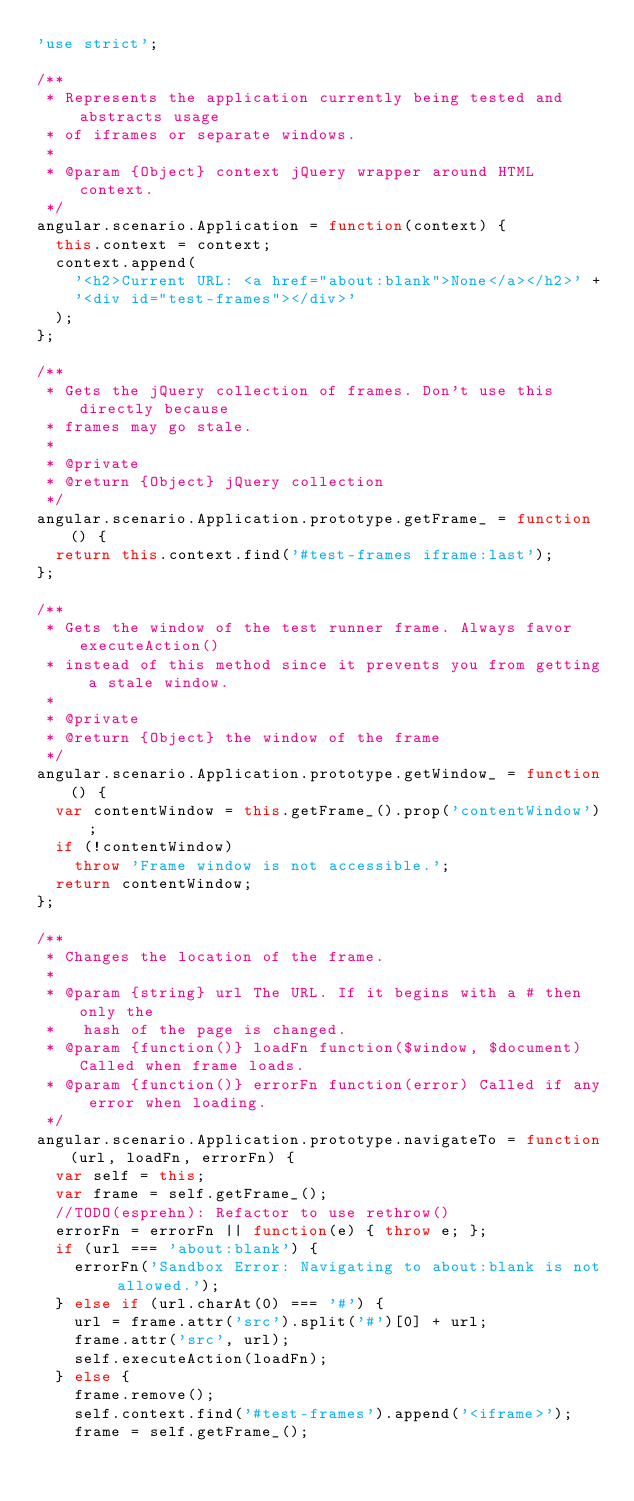Convert code to text. <code><loc_0><loc_0><loc_500><loc_500><_JavaScript_>'use strict';

/**
 * Represents the application currently being tested and abstracts usage
 * of iframes or separate windows.
 *
 * @param {Object} context jQuery wrapper around HTML context.
 */
angular.scenario.Application = function(context) {
  this.context = context;
  context.append(
    '<h2>Current URL: <a href="about:blank">None</a></h2>' +
    '<div id="test-frames"></div>'
  );
};

/**
 * Gets the jQuery collection of frames. Don't use this directly because
 * frames may go stale.
 *
 * @private
 * @return {Object} jQuery collection
 */
angular.scenario.Application.prototype.getFrame_ = function() {
  return this.context.find('#test-frames iframe:last');
};

/**
 * Gets the window of the test runner frame. Always favor executeAction()
 * instead of this method since it prevents you from getting a stale window.
 *
 * @private
 * @return {Object} the window of the frame
 */
angular.scenario.Application.prototype.getWindow_ = function() {
  var contentWindow = this.getFrame_().prop('contentWindow');
  if (!contentWindow)
    throw 'Frame window is not accessible.';
  return contentWindow;
};

/**
 * Changes the location of the frame.
 *
 * @param {string} url The URL. If it begins with a # then only the
 *   hash of the page is changed.
 * @param {function()} loadFn function($window, $document) Called when frame loads.
 * @param {function()} errorFn function(error) Called if any error when loading.
 */
angular.scenario.Application.prototype.navigateTo = function(url, loadFn, errorFn) {
  var self = this;
  var frame = self.getFrame_();
  //TODO(esprehn): Refactor to use rethrow()
  errorFn = errorFn || function(e) { throw e; };
  if (url === 'about:blank') {
    errorFn('Sandbox Error: Navigating to about:blank is not allowed.');
  } else if (url.charAt(0) === '#') {
    url = frame.attr('src').split('#')[0] + url;
    frame.attr('src', url);
    self.executeAction(loadFn);
  } else {
    frame.remove();
    self.context.find('#test-frames').append('<iframe>');
    frame = self.getFrame_();
</code> 